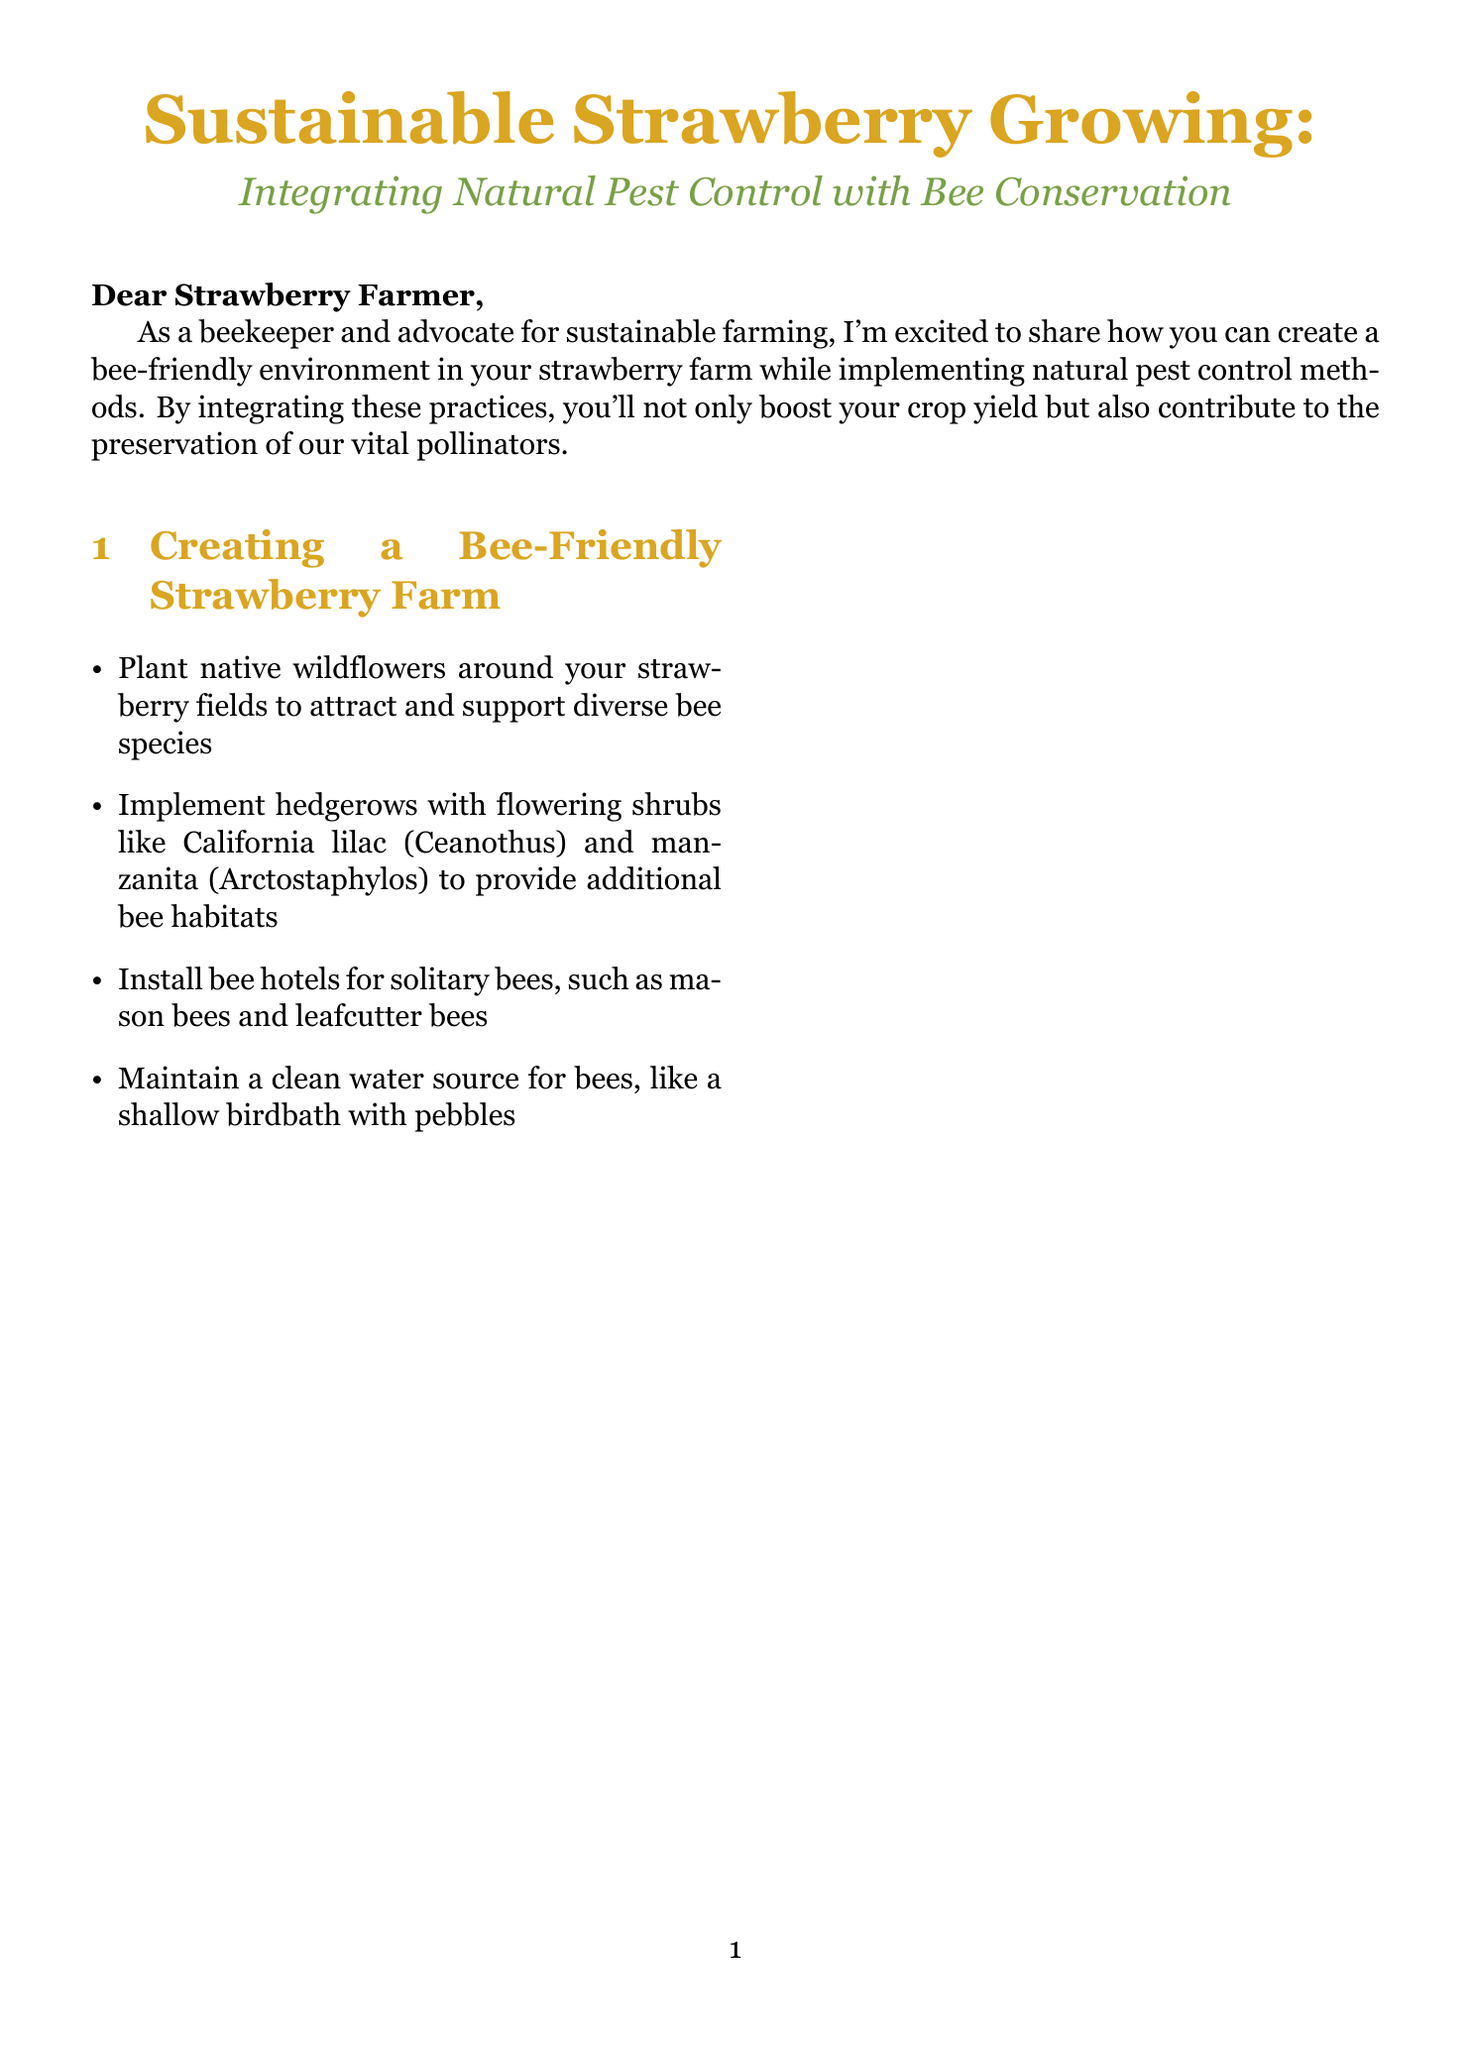What is the title of the newsletter? The title is stated at the beginning of the document.
Answer: Sustainable Strawberry Growing: Integrating Natural Pest Control with Bee Conservation What is one method to create a bee-friendly environment mentioned in the newsletter? The document lists several methods in the "Creating a Bee-Friendly Strawberry Farm" section.
Answer: Plant native wildflowers What was the percentage increase in strawberry yield at Bee Haven Strawberry Farm? This information is provided in the case study section with specific details on results.
Answer: 20% Which beneficial insect is suggested to control aphids? This insect is mentioned in the "Natural Pest Control Methods" section.
Answer: Ladybugs How much did pesticide use reduce at Bee Haven Strawberry Farm? The percentage reduction is clearly stated in the case study section.
Answer: 80% What is the contact name for consultation? The contact information is provided at the end of the document.
Answer: Sarah Bee-nnett What type of irrigation system is recommended for sustainable practices? The newsletter advises on irrigation systems in the "Sustainable Irrigation Practices" section.
Answer: Drip irrigation system What is the main purpose of implementing natural pest control methods according to the newsletter? The rationale is discussed in the introduction and throughout the sections.
Answer: To boost crop yield and preserve pollinators 